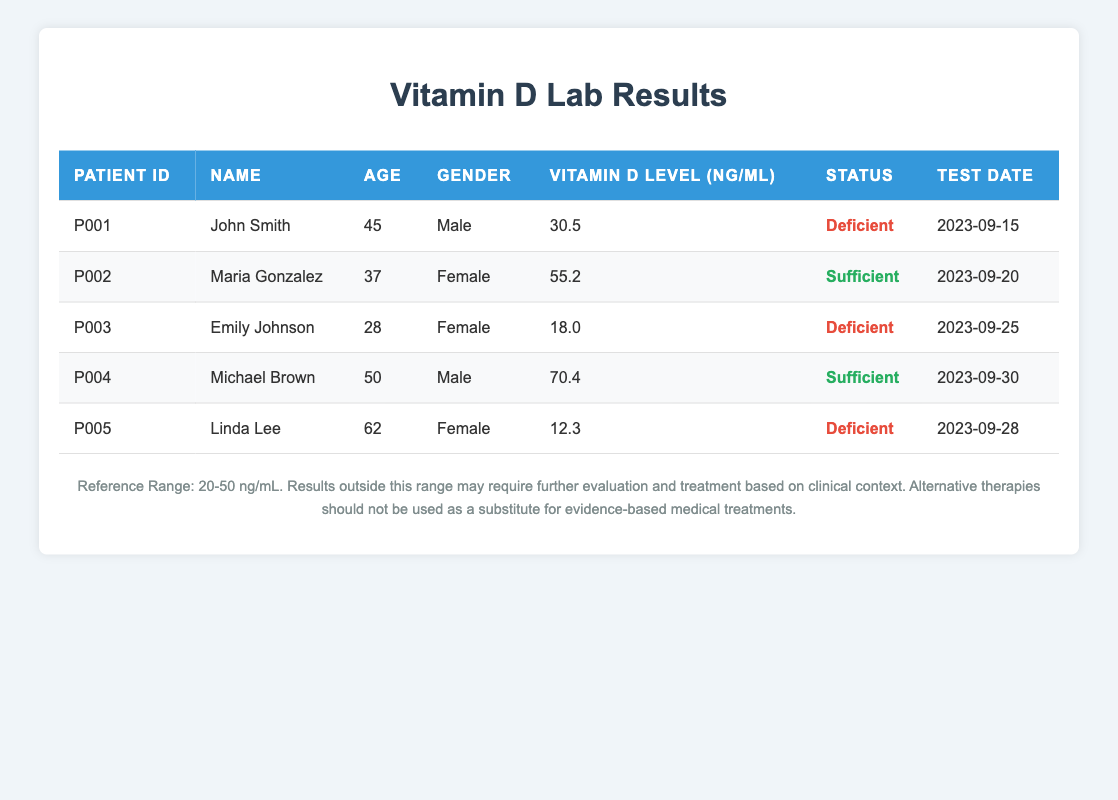What is the vitamin D level of Maria Gonzalez? Maria Gonzalez's vitamin D level is listed in the table under the "Vitamin D Level (ng/mL)" column. It shows a value of 55.2.
Answer: 55.2 How many patients have deficient vitamin D levels? By scanning the "Status" column, we can identify the patients labeled as "Deficient." There are three patients with deficient levels: John Smith, Emily Johnson, and Linda Lee.
Answer: 3 What is the vitamin D level range for sufficient status? The reference range for vitamin D levels is provided in the footnote of the table as 20-50 ng/mL. Therefore, any vitamin D level above 50 ng/mL is considered sufficient.
Answer: Above 50 ng/mL Who has the highest vitamin D level? Looking through the vitamin D levels listed, Michael Brown has the highest value at 70.4 ng/mL, which is greater than all other patients' levels.
Answer: Michael Brown What is the average vitamin D level of all patients? To find the average, first, sum all vitamin D levels: 30.5 + 55.2 + 18.0 + 70.4 + 12.3 = 186.4. Then, divide this total by the number of patients, which is 5: 186.4 / 5 = 37.28.
Answer: 37.28 Is Linda Lee's vitamin D level within the reference range? Linda Lee's vitamin D level is 12.3 ng/mL. The reference range is 20-50 ng/mL, so her level falls outside this range. This means the answer is no; it is not within the reference range.
Answer: No How many males have sufficient vitamin D levels? By examining the "Gender" and "Status" columns, we find that only Michael Brown is male and has a sufficient level (70.4 ng/mL). Therefore, there is one male with sufficient vitamin D levels.
Answer: 1 What is the difference between the highest and lowest vitamin D levels? The highest vitamin D level is from Michael Brown at 70.4 ng/mL and the lowest is Linda Lee's level at 12.3 ng/mL. To find the difference, subtract the lowest from the highest: 70.4 - 12.3 = 58.1 ng/mL.
Answer: 58.1 ng/mL 